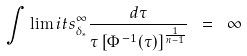Convert formula to latex. <formula><loc_0><loc_0><loc_500><loc_500>\int \lim i t s _ { \delta _ { * } } ^ { \infty } \frac { d \tau } { \tau \left [ \Phi ^ { \, - 1 } ( \tau ) \right ] ^ { \frac { 1 } { n - 1 } } } \ = \ \infty</formula> 